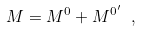Convert formula to latex. <formula><loc_0><loc_0><loc_500><loc_500>M = M ^ { 0 } + M ^ { 0 ^ { \prime } } \ ,</formula> 